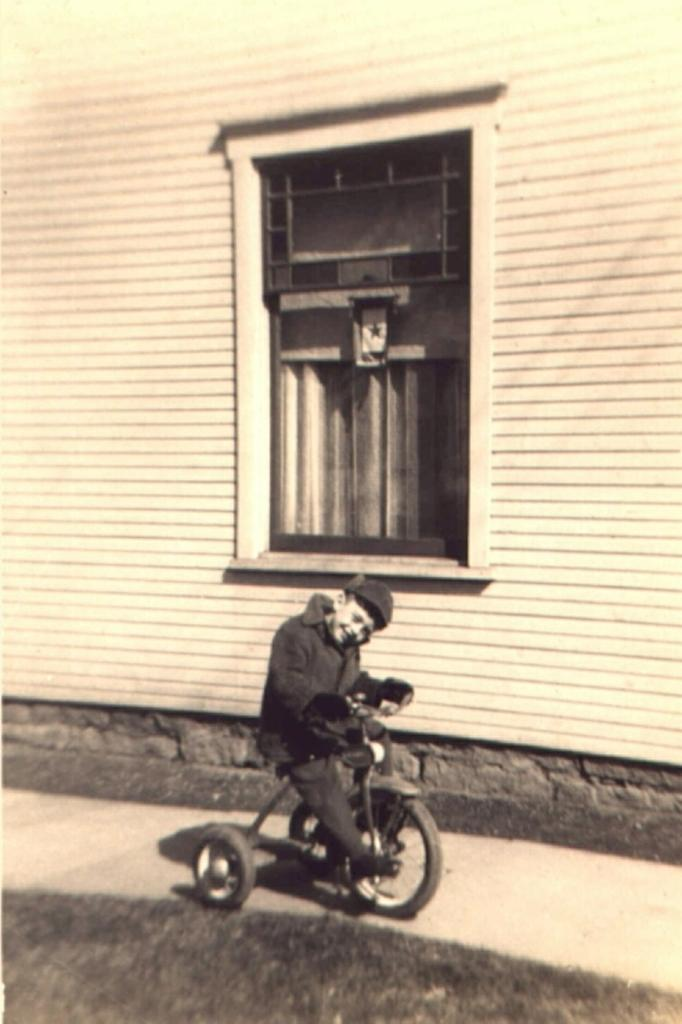What is the main subject of the image? There is a child in the image. What is the child doing in the image? The child is riding a bicycle. Where is the child riding the bicycle? The child is on a path. What can be seen in the background of the image? There is a building in the background of the image. Can you describe the building in the image? The building has a window. Can you tell me how many streams are visible in the image? There are no streams visible in the image. What type of ground is the child riding the bicycle on? The provided facts do not mention the type of ground the child is riding on, so we cannot definitively answer that question. 